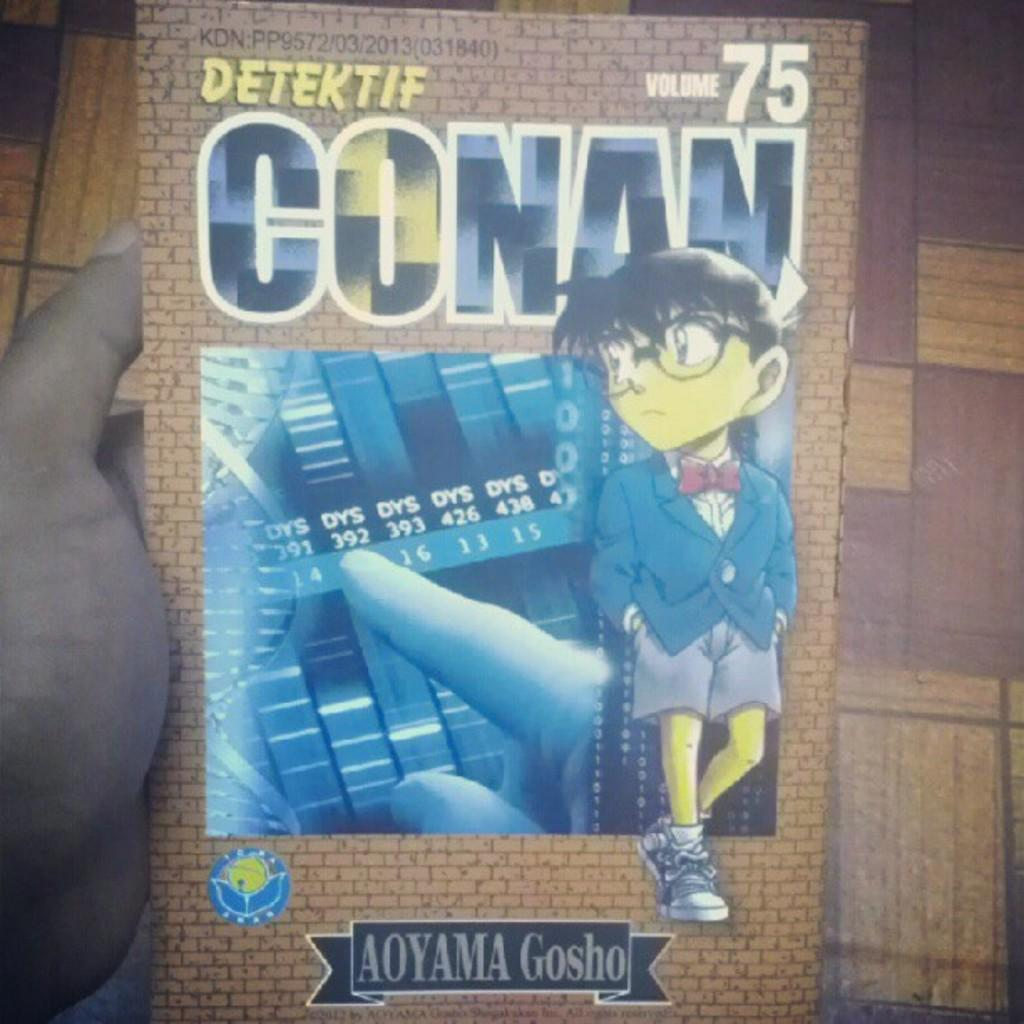<image>
Write a terse but informative summary of the picture. Poster for an anime named Detektif Conan by Aoyama Gosho. 